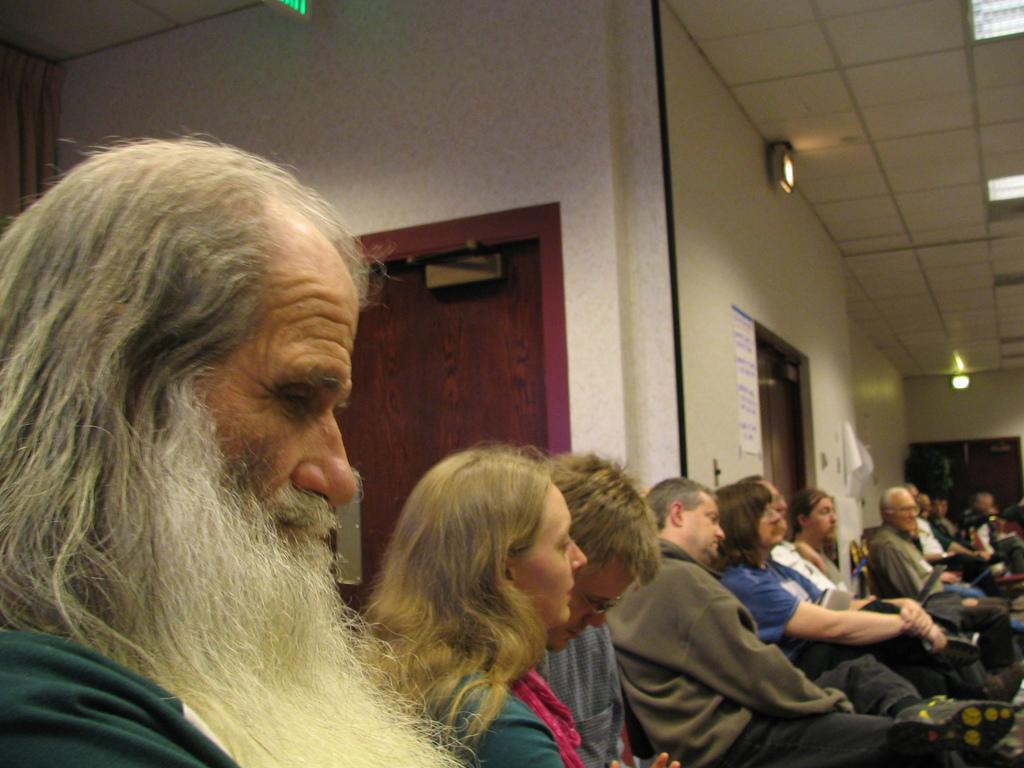How would you summarize this image in a sentence or two? In this image I can see number of persons are sitting, the brown colored door, the white colored wall, the ceiling, few lights to the ceiling, the cream colored wall and few posts attached to the wall. 